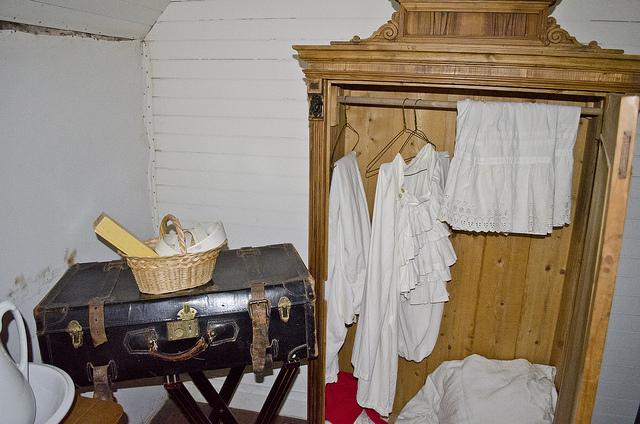How many white shirts?
Short answer required. 2. Where are clothes hanging?
Keep it brief. Closet. What material is the closet?
Short answer required. Shirts. Does the room look messy?
Write a very short answer. Yes. Is the suitcase new?
Write a very short answer. No. 